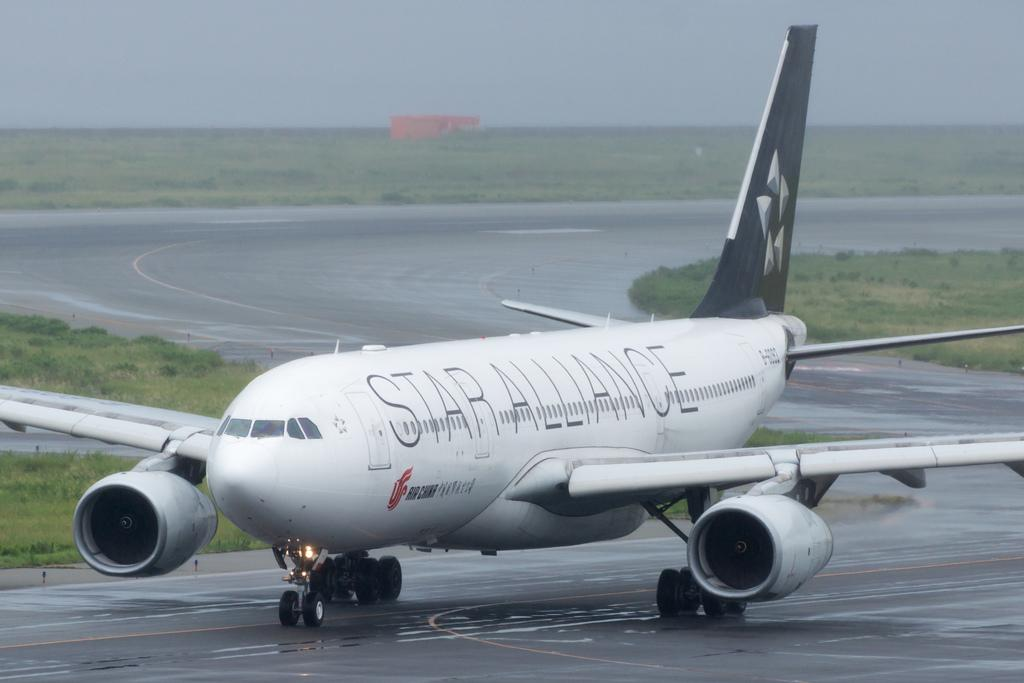Provide a one-sentence caption for the provided image. A Star Alliance airplane is parked but started on a runway. 